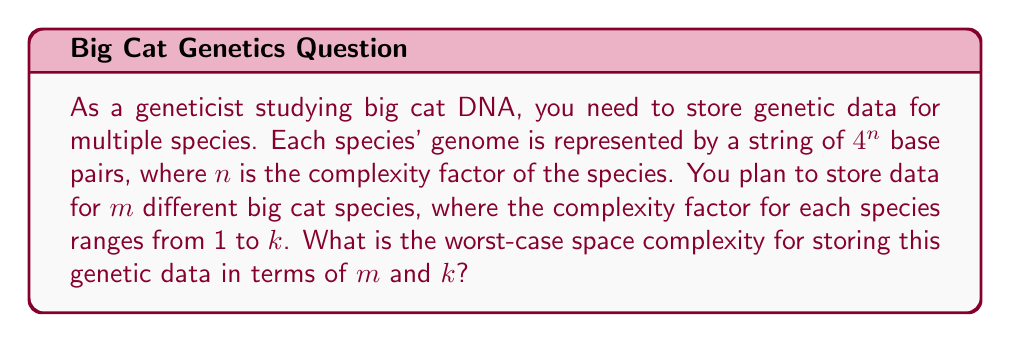Teach me how to tackle this problem. To solve this problem, let's break it down step-by-step:

1) For a single species with complexity factor $n$, the genome is represented by $4^n$ base pairs.

2) The space required to store this genome is proportional to the number of base pairs. So, for one species, the space complexity is $O(4^n)$.

3) We have $m$ different species, and the complexity factor for each species can range from 1 to $k$.

4) In the worst-case scenario, all $m$ species would have the maximum complexity factor $k$.

5) Therefore, the worst-case space requirement for a single species would be $O(4^k)$.

6) For $m$ species, we multiply this by $m$, giving us $O(m \cdot 4^k)$.

7) We can simplify this notation:
   $O(m \cdot 4^k) = O(m \cdot 2^{2k}) = O(m \cdot 2^{2k})$

8) This represents the worst-case space complexity for storing the genetic data of $m$ big cat species with a maximum complexity factor of $k$.
Answer: The worst-case space complexity is $O(m \cdot 2^{2k})$. 